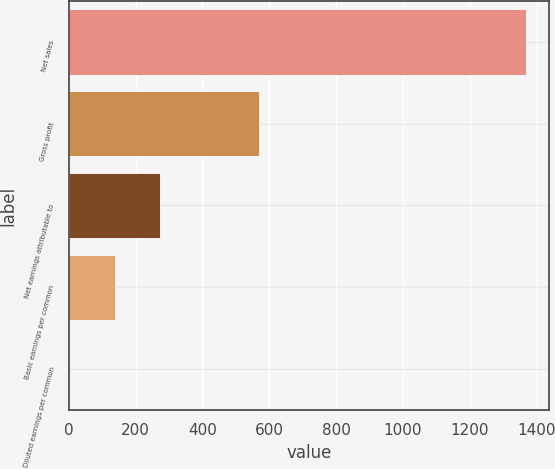Convert chart to OTSL. <chart><loc_0><loc_0><loc_500><loc_500><bar_chart><fcel>Net sales<fcel>Gross profit<fcel>Net earnings attributable to<fcel>Basic earnings per common<fcel>Diluted earnings per common<nl><fcel>1368.4<fcel>568.4<fcel>274.67<fcel>137.95<fcel>1.23<nl></chart> 